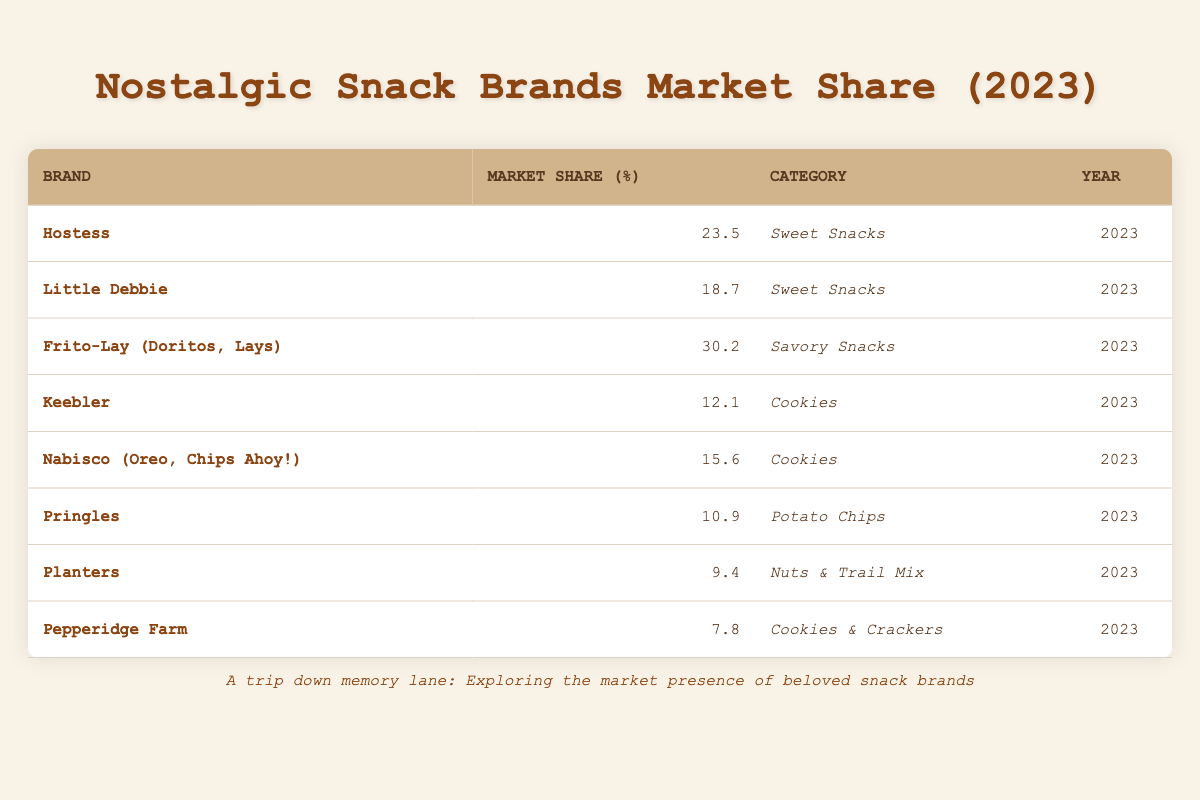What is the market share percentage of Hostess? The market share percentage for Hostess is listed as 23.5 in the table under the column for market share percentage.
Answer: 23.5 Which brand has the highest market share in savory snacks? By scanning the table, Frito-Lay (Doritos, Lays) has the highest market share in savory snacks at 30.2, while other brands in the same category have lower percentages.
Answer: Frito-Lay (Doritos, Lays) What is the combined market share of Little Debbie and Keebler? The market share for Little Debbie is 18.7 and for Keebler it is 12.1. Adding these together gives 18.7 + 12.1 = 30.8.
Answer: 30.8 Is Pepperidge Farm’s market share greater than Pringles’? The market share for Pepperidge Farm is 7.8 while for Pringles it is 10.9. Since 7.8 is less than 10.9, the statement is false.
Answer: No Which category has the brand with the lowest market share? Looking at the table, the brand with the lowest market share is Pepperidge Farm at 7.8, which is categorized under Cookies & Crackers.
Answer: Cookies & Crackers What is the average market share of the cookie brands listed? The cookie brands listed are Keebler (12.1) and Nabisco (15.6). To find the average, we sum the market shares (12.1 + 15.6 = 27.7) and divide by 2, giving an average of 27.7 / 2 = 13.85.
Answer: 13.85 Which sweet snack brand has a market share closest to 20 percent? Hostess has a market share of 23.5, and Little Debbie has 18.7. Little Debbie is closer to 20 percent since it's just 1.3 away compared to Hostess' 3.5, making Little Debbie the answer.
Answer: Little Debbie Are there any brands in the nuts and trail mix category? The table lists Planters under the Nuts & Trail Mix category, which indicates that there is indeed a brand in that category.
Answer: Yes 